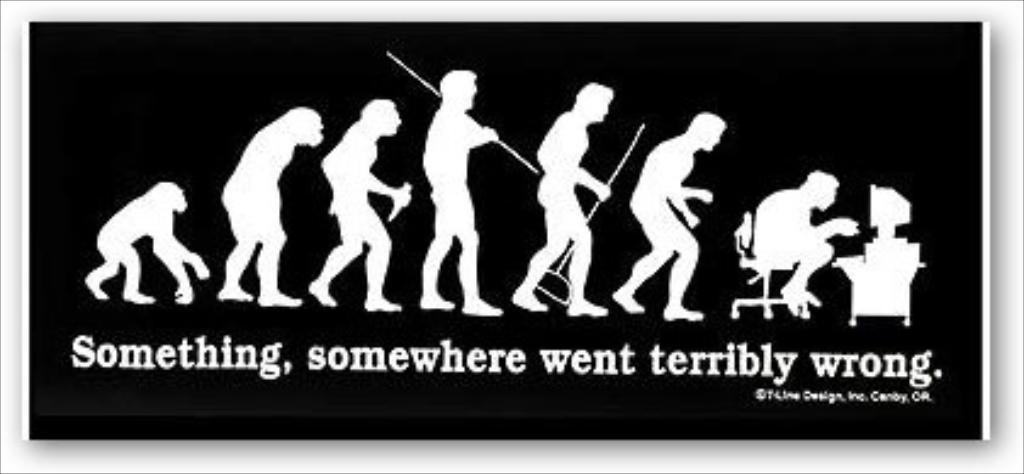<image>
Relay a brief, clear account of the picture shown. a black and white poster of apes evolving to men crouching over a computer says Terribly Wrong 